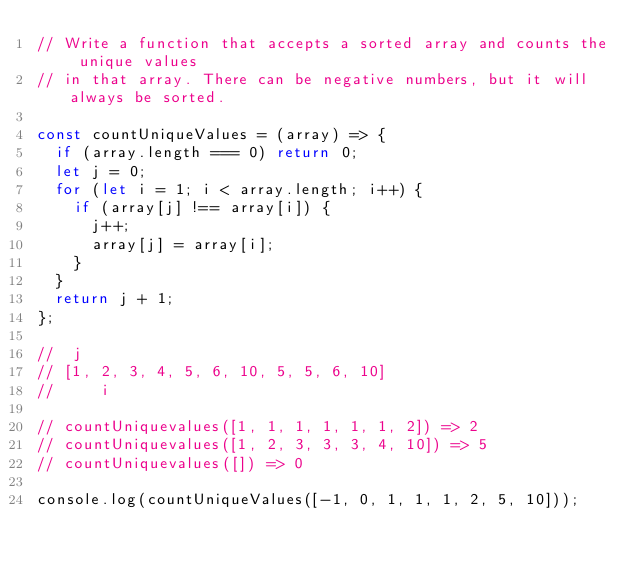Convert code to text. <code><loc_0><loc_0><loc_500><loc_500><_JavaScript_>// Write a function that accepts a sorted array and counts the unique values
// in that array. There can be negative numbers, but it will always be sorted.

const countUniqueValues = (array) => {
  if (array.length === 0) return 0;
  let j = 0;
  for (let i = 1; i < array.length; i++) {
    if (array[j] !== array[i]) {
      j++;
      array[j] = array[i];
    }
  }
  return j + 1;
};

//  j
// [1, 2, 3, 4, 5, 6, 10, 5, 5, 6, 10]
//     i

// countUniquevalues([1, 1, 1, 1, 1, 1, 2]) => 2
// countUniquevalues([1, 2, 3, 3, 3, 4, 10]) => 5
// countUniquevalues([]) => 0

console.log(countUniqueValues([-1, 0, 1, 1, 1, 2, 5, 10]));
</code> 